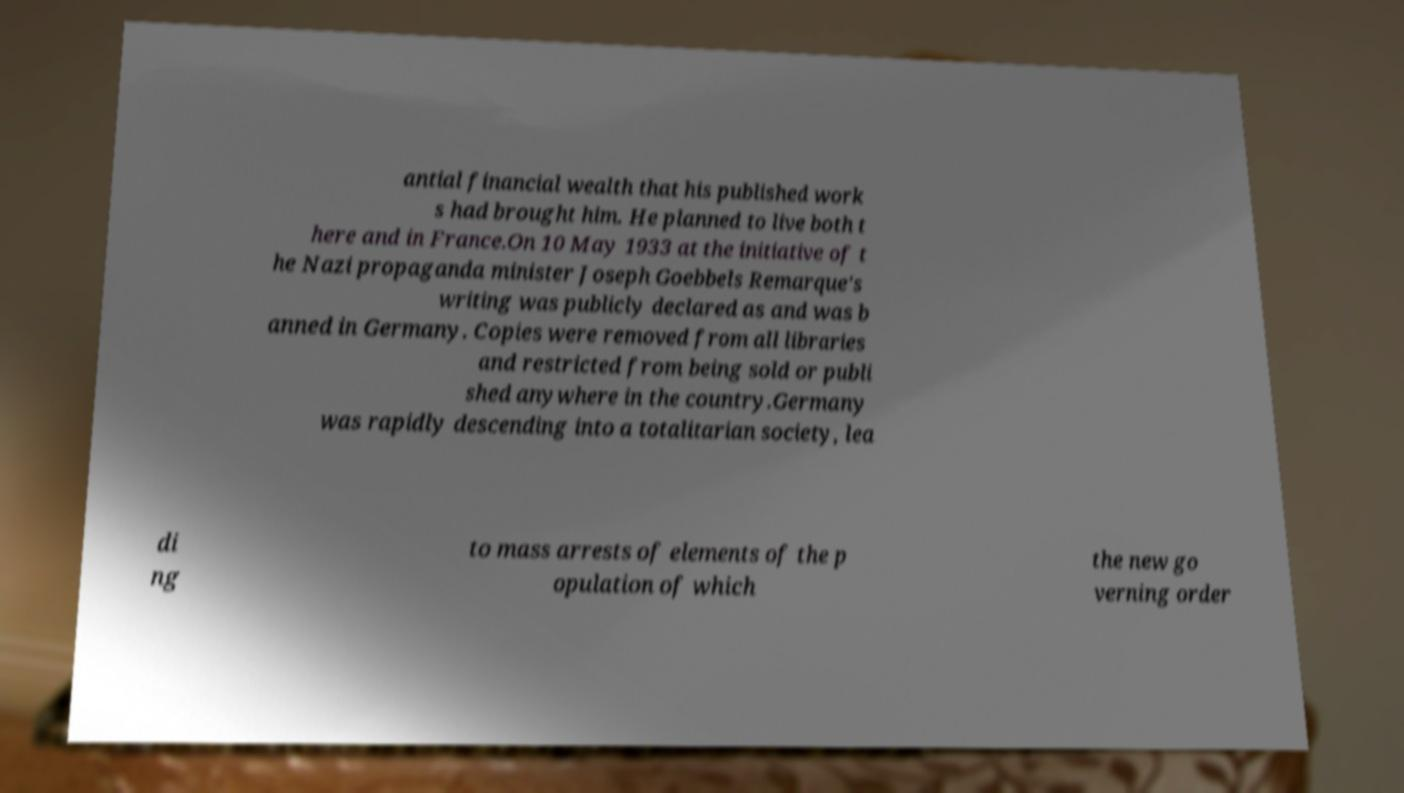There's text embedded in this image that I need extracted. Can you transcribe it verbatim? antial financial wealth that his published work s had brought him. He planned to live both t here and in France.On 10 May 1933 at the initiative of t he Nazi propaganda minister Joseph Goebbels Remarque's writing was publicly declared as and was b anned in Germany. Copies were removed from all libraries and restricted from being sold or publi shed anywhere in the country.Germany was rapidly descending into a totalitarian society, lea di ng to mass arrests of elements of the p opulation of which the new go verning order 